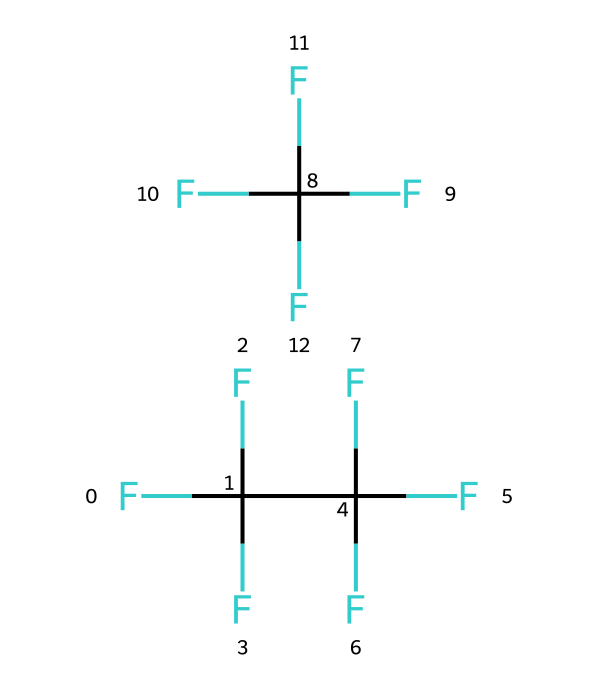What is the chemical name of the refrigerant represented? The SMILES notation indicates that the refrigerant is a blend of two compounds with fluorinated carbon chains, specifically tetrafluoropropene and pentafluoropropane. The name for this blend is R-410A.
Answer: R-410A How many carbon atoms are present in R-410A? In the provided SMILES representation, there are a total of 5 carbon atoms: 3 from the first compound and 2 from the second compound.
Answer: 5 What is a key property of R-410A in terms of environmental impact? R-410A is noted for having a lower ozone depletion potential than some older refrigerants, but it does have a significant global warming potential.
Answer: global warming potential How many fluorine atoms are present in R-410A? By analyzing the SMILES, there are 8 fluorine atoms in total: 5 from the first compound and 3 from the second compound.
Answer: 8 Why is R-410A favored in modern HVAC systems? R-410A is favored because of its efficient heat transfer properties, stability in the system, and lower environmental impact compared to its predecessors.
Answer: efficiency and stability What type of bond characterizes the carbon-fluorine interactions in R-410A? The carbon-fluorine bonds in R-410A are characterized as strong polar covalent bonds due to the significant electronegativity difference between carbon and fluorine.
Answer: polar covalent What phase does R-410A predominantly exist in at room temperature? R-410A is typically a vapor at room temperature, used as a refrigerant in its gaseous state.
Answer: vapor 